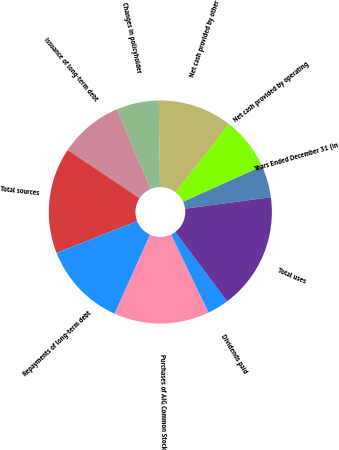<chart> <loc_0><loc_0><loc_500><loc_500><pie_chart><fcel>Years Ended December 31 (in<fcel>Net cash provided by operating<fcel>Net cash provided by other<fcel>Changes in policyholder<fcel>Issuance of long-term debt<fcel>Total sources<fcel>Repayments of long-term debt<fcel>Purchases of AIG Common Stock<fcel>Dividends paid<fcel>Total uses<nl><fcel>4.63%<fcel>7.7%<fcel>10.77%<fcel>6.16%<fcel>9.23%<fcel>15.37%<fcel>12.3%<fcel>13.84%<fcel>3.1%<fcel>16.9%<nl></chart> 